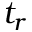<formula> <loc_0><loc_0><loc_500><loc_500>t _ { r }</formula> 